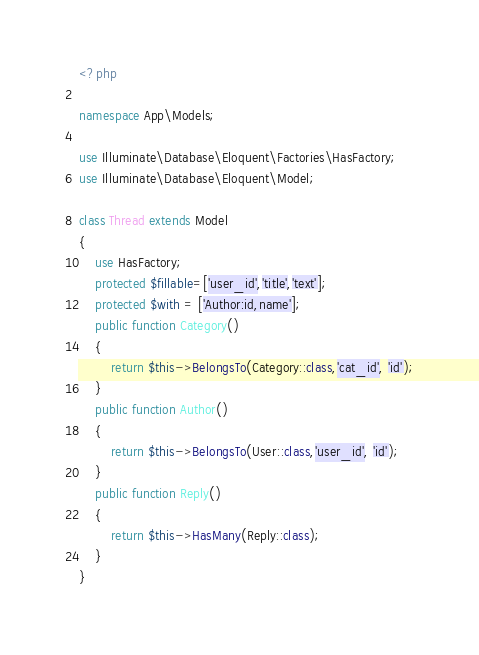<code> <loc_0><loc_0><loc_500><loc_500><_PHP_><?php

namespace App\Models;

use Illuminate\Database\Eloquent\Factories\HasFactory;
use Illuminate\Database\Eloquent\Model;

class Thread extends Model
{
    use HasFactory;
    protected $fillable=['user_id','title','text'];
    protected $with = ['Author:id,name'];
    public function Category()
    {
        return $this->BelongsTo(Category::class,'cat_id', 'id');
    }
    public function Author()
    {
        return $this->BelongsTo(User::class,'user_id', 'id');
    }
    public function Reply()
    {
        return $this->HasMany(Reply::class);
    }
}
</code> 